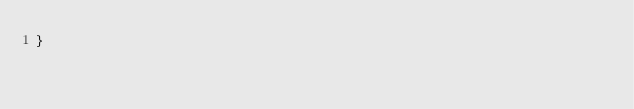<code> <loc_0><loc_0><loc_500><loc_500><_CSS_>}</code> 